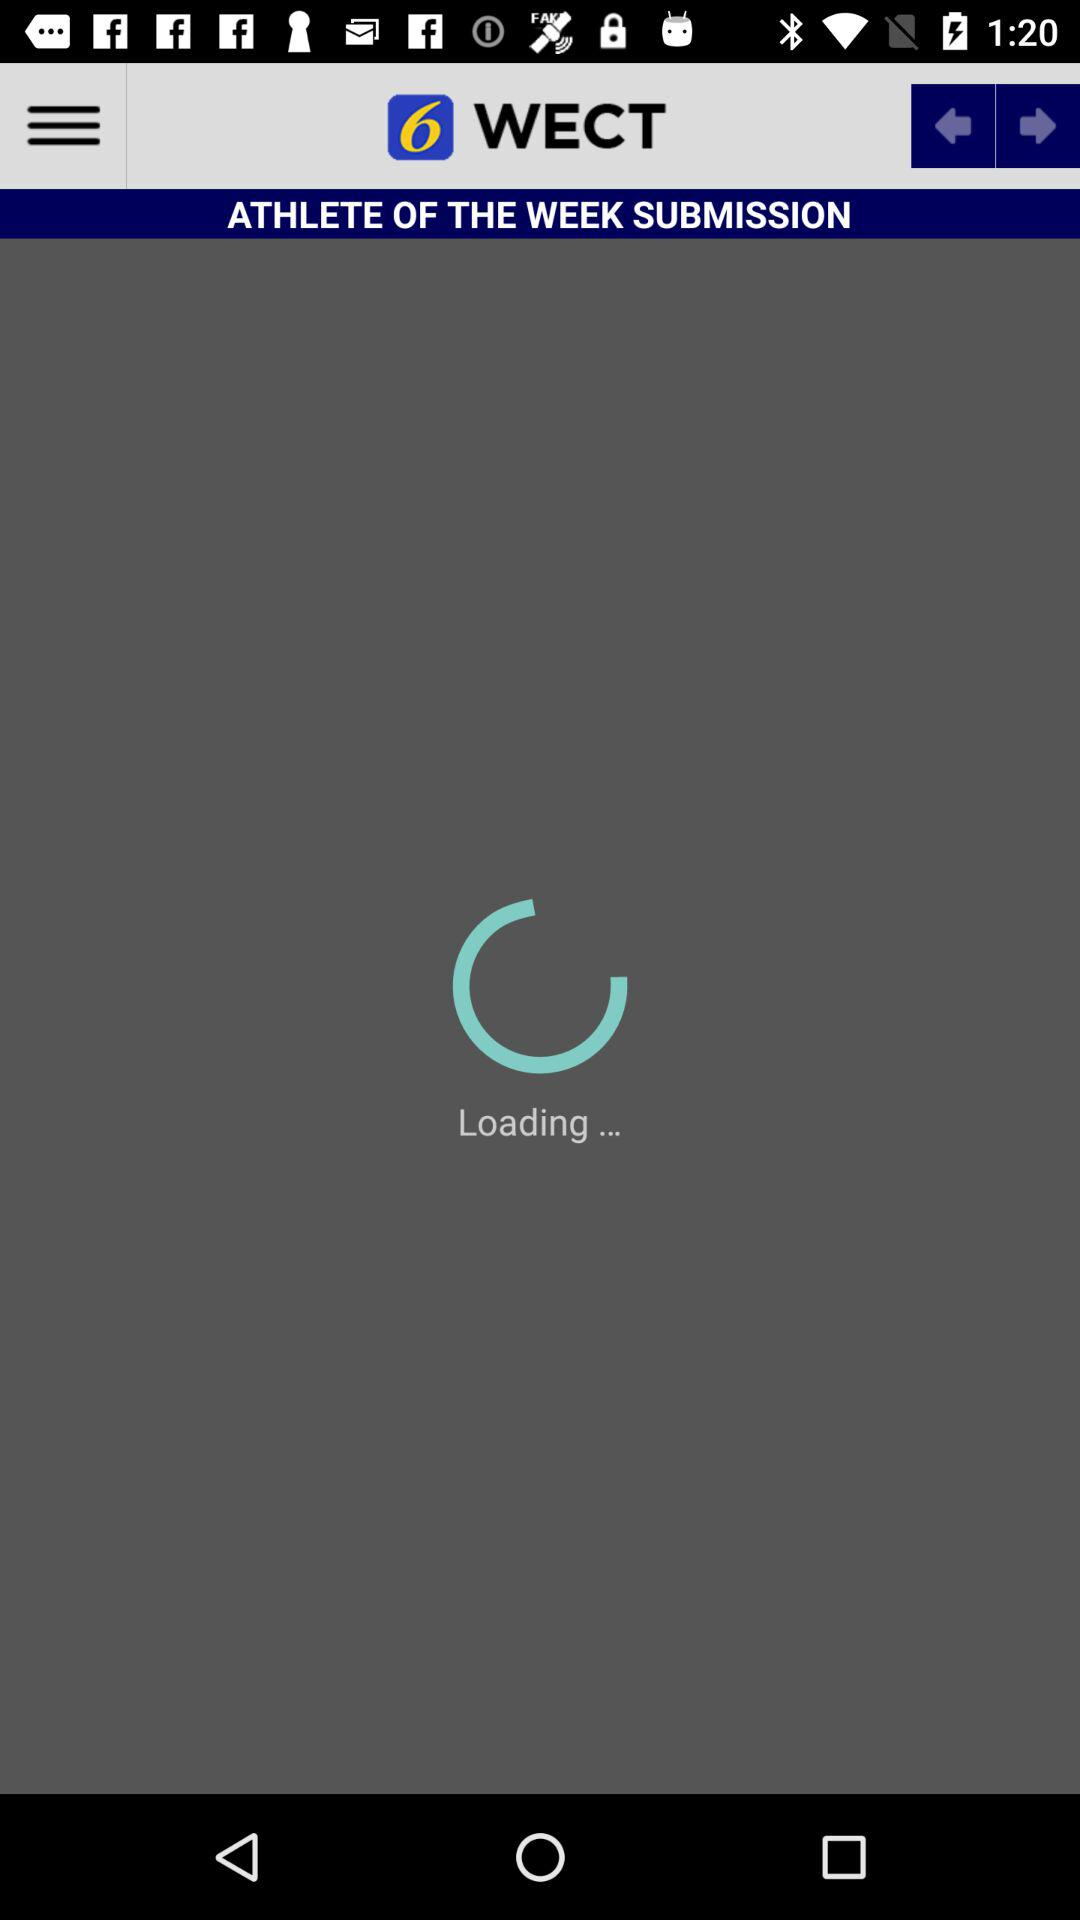Who is the athlete of the week?
When the provided information is insufficient, respond with <no answer>. <no answer> 